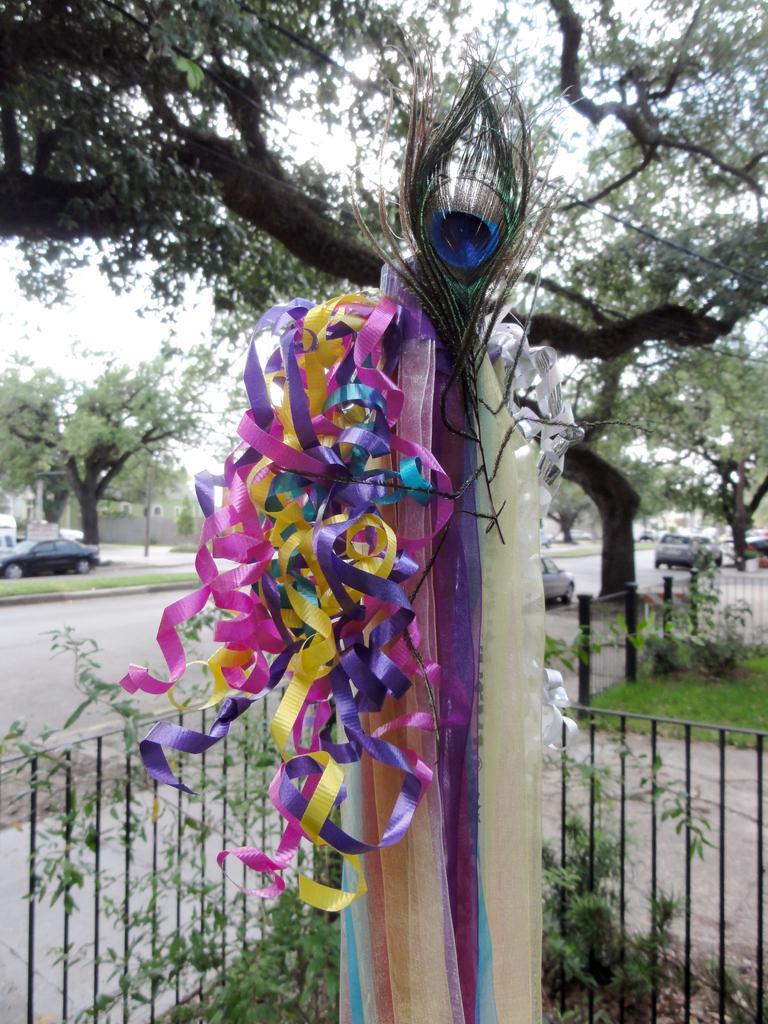Please provide a concise description of this image. In this picture I can see a peacock feather and some decorative items, there are plants, iron grilles, there are vehicles on the road, there are trees, and in the background there is sky. 